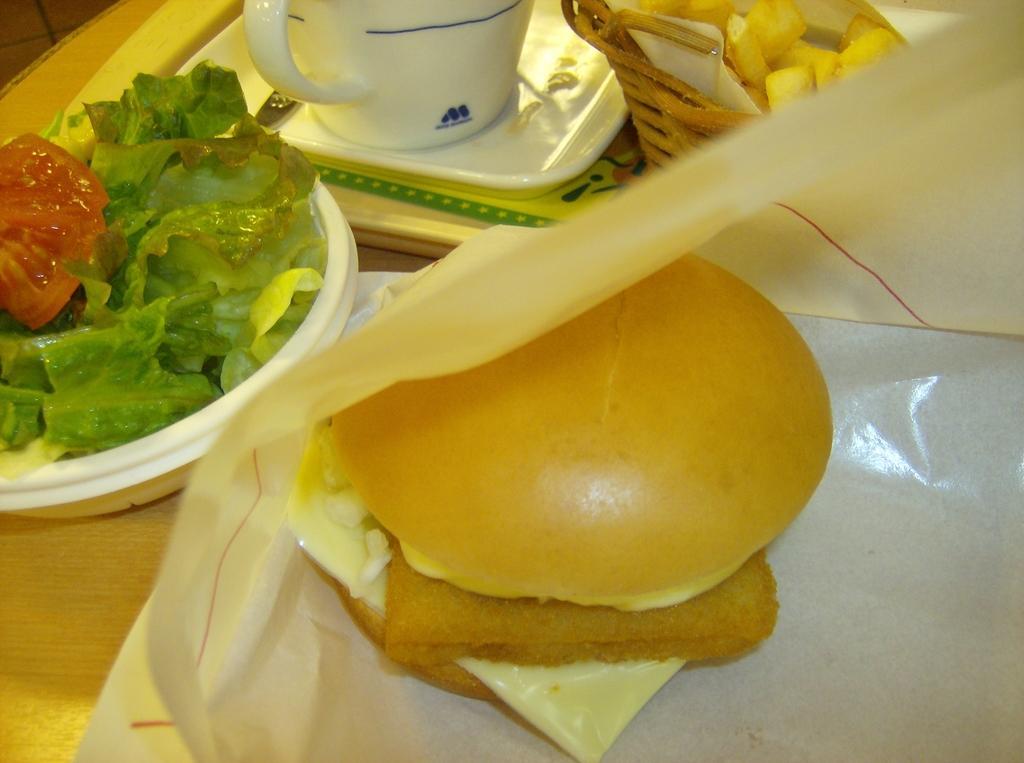In one or two sentences, can you explain what this image depicts? In this image there is a table with a cup and spoon on the tray and some other food items are arranged on the table. 